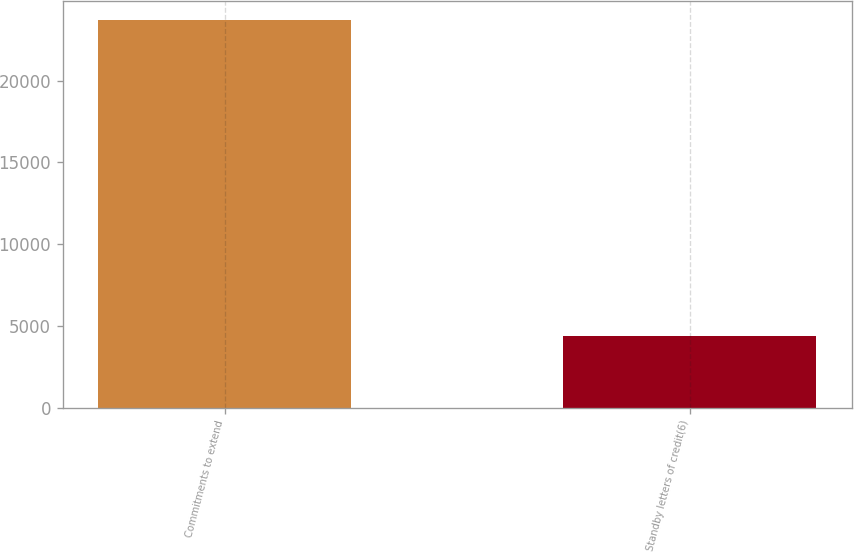Convert chart. <chart><loc_0><loc_0><loc_500><loc_500><bar_chart><fcel>Commitments to extend<fcel>Standby letters of credit(6)<nl><fcel>23715<fcel>4376<nl></chart> 